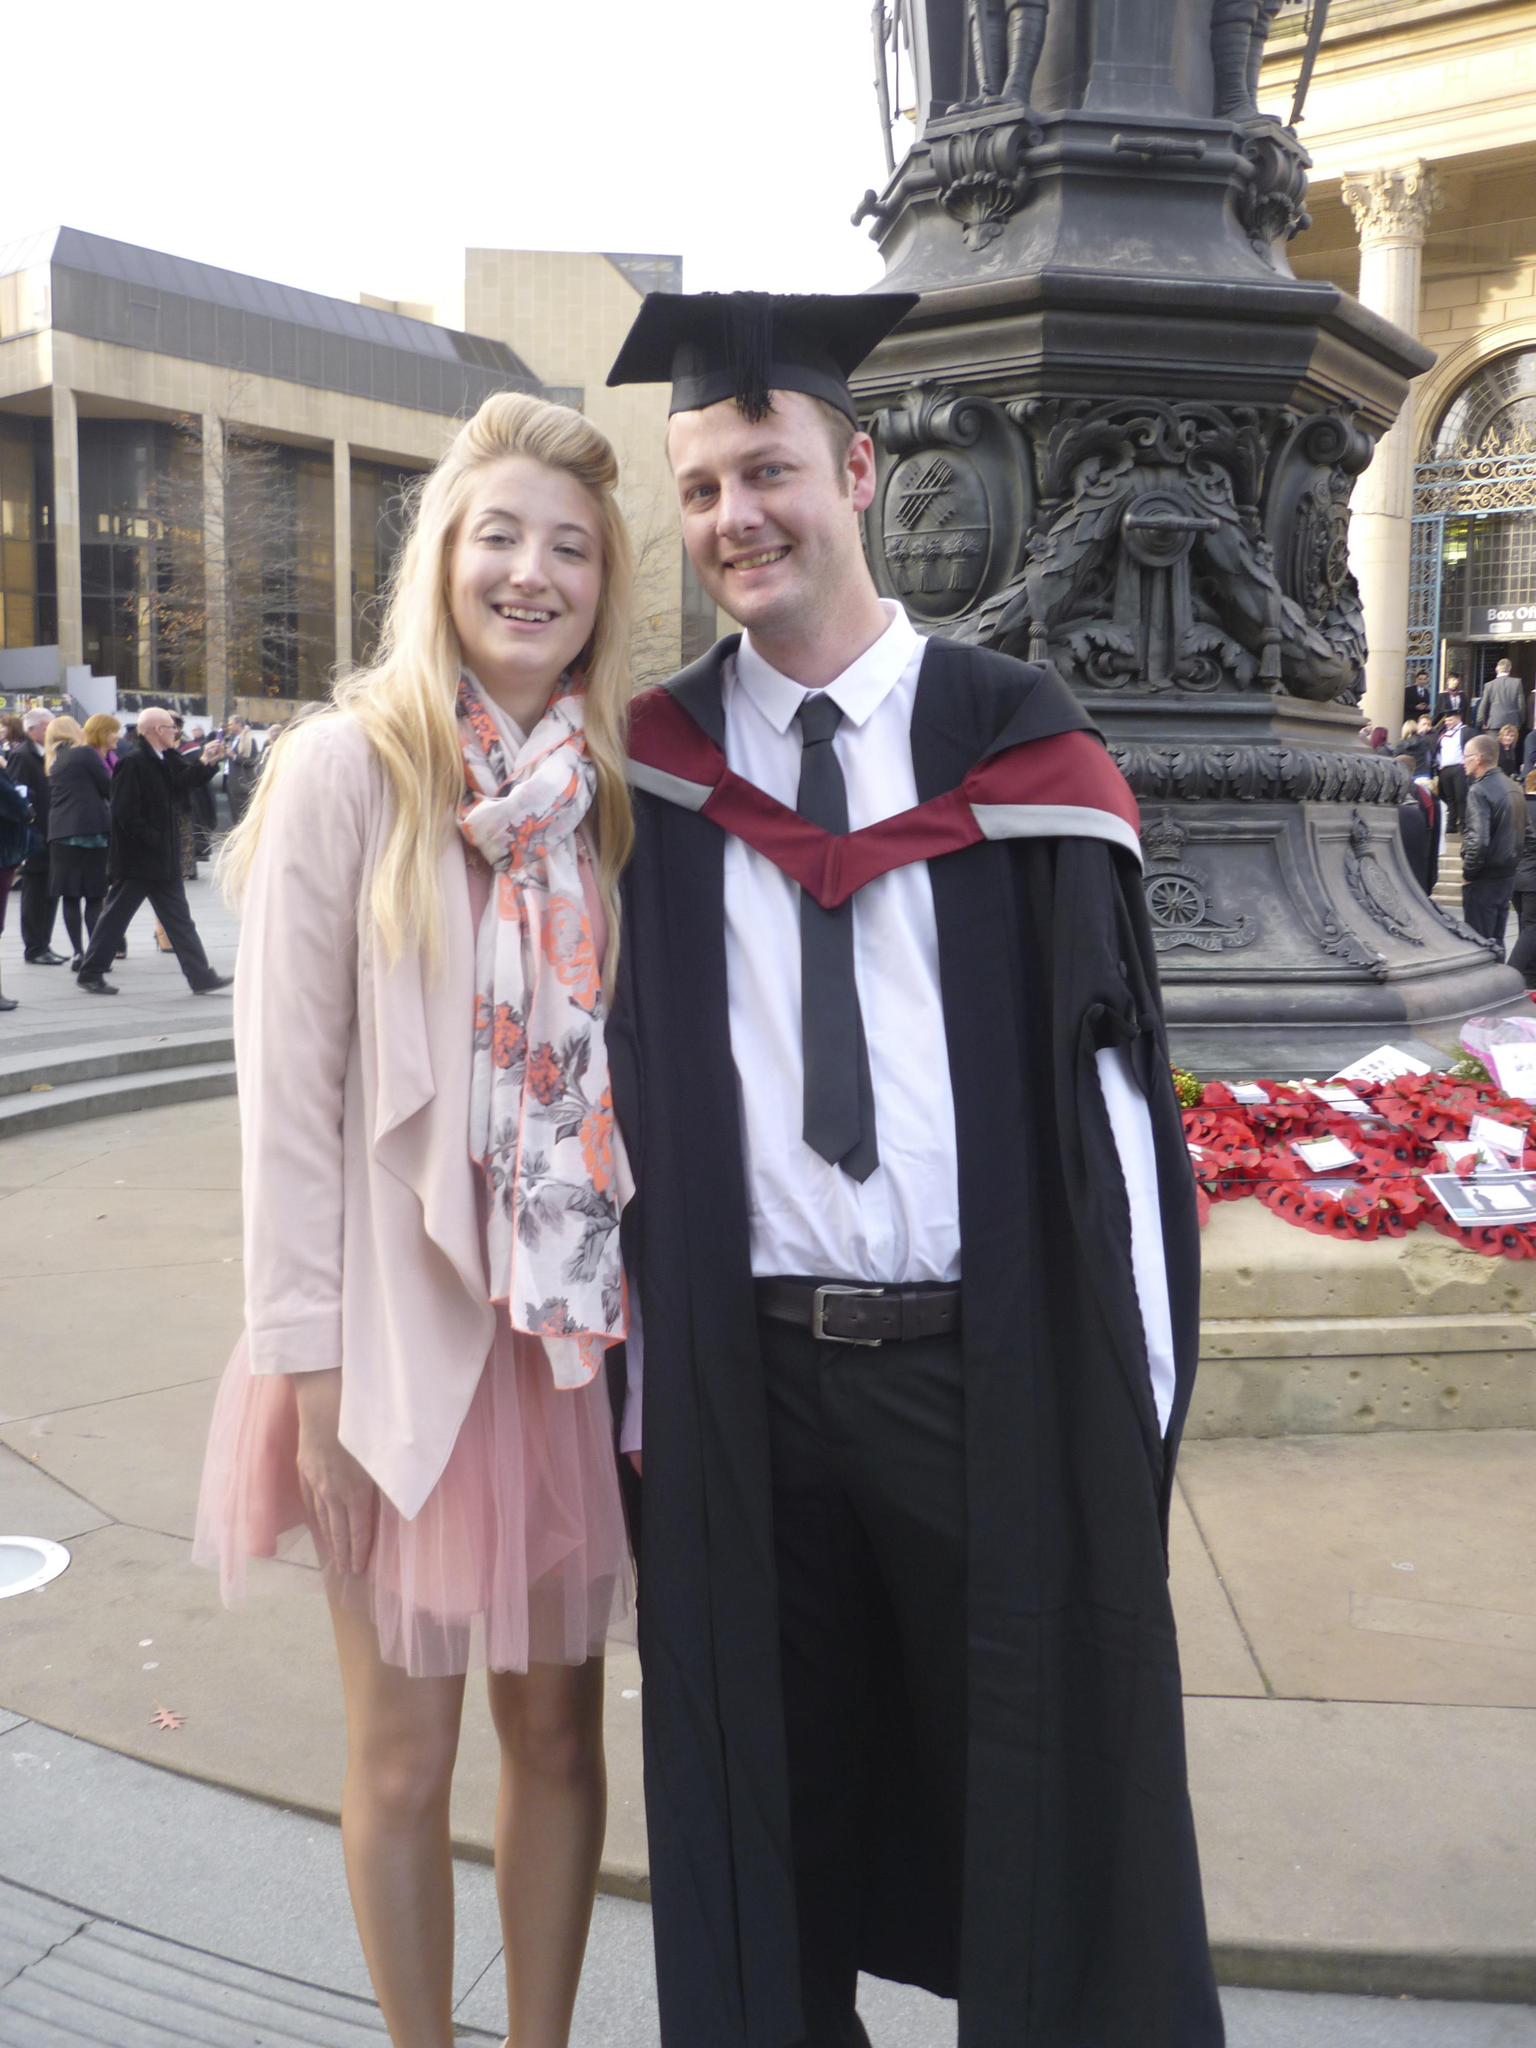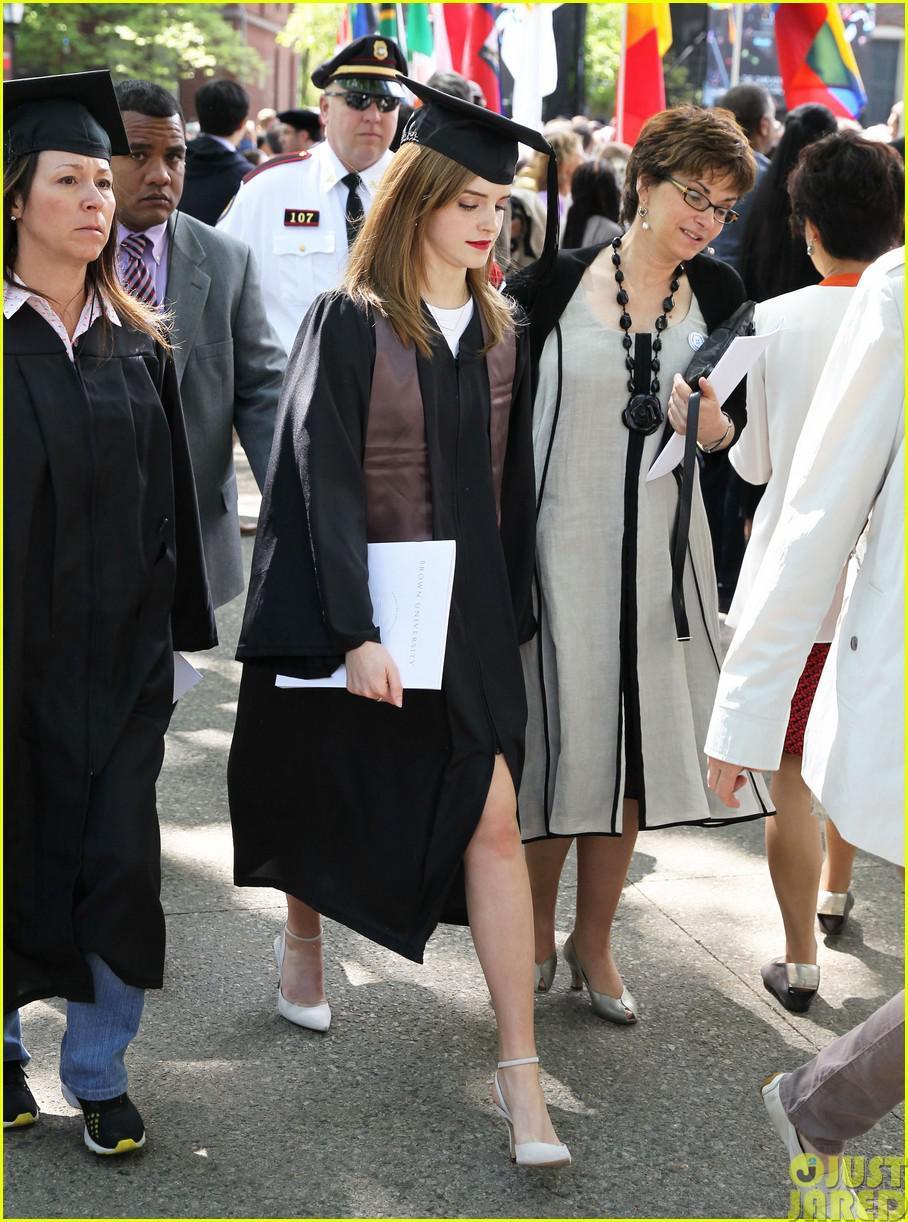The first image is the image on the left, the second image is the image on the right. For the images shown, is this caption "One image shows one male graduate posing with one female in the foreground." true? Answer yes or no. Yes. 